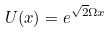Convert formula to latex. <formula><loc_0><loc_0><loc_500><loc_500>U ( x ) = e ^ { \sqrt { 2 } \Omega x }</formula> 